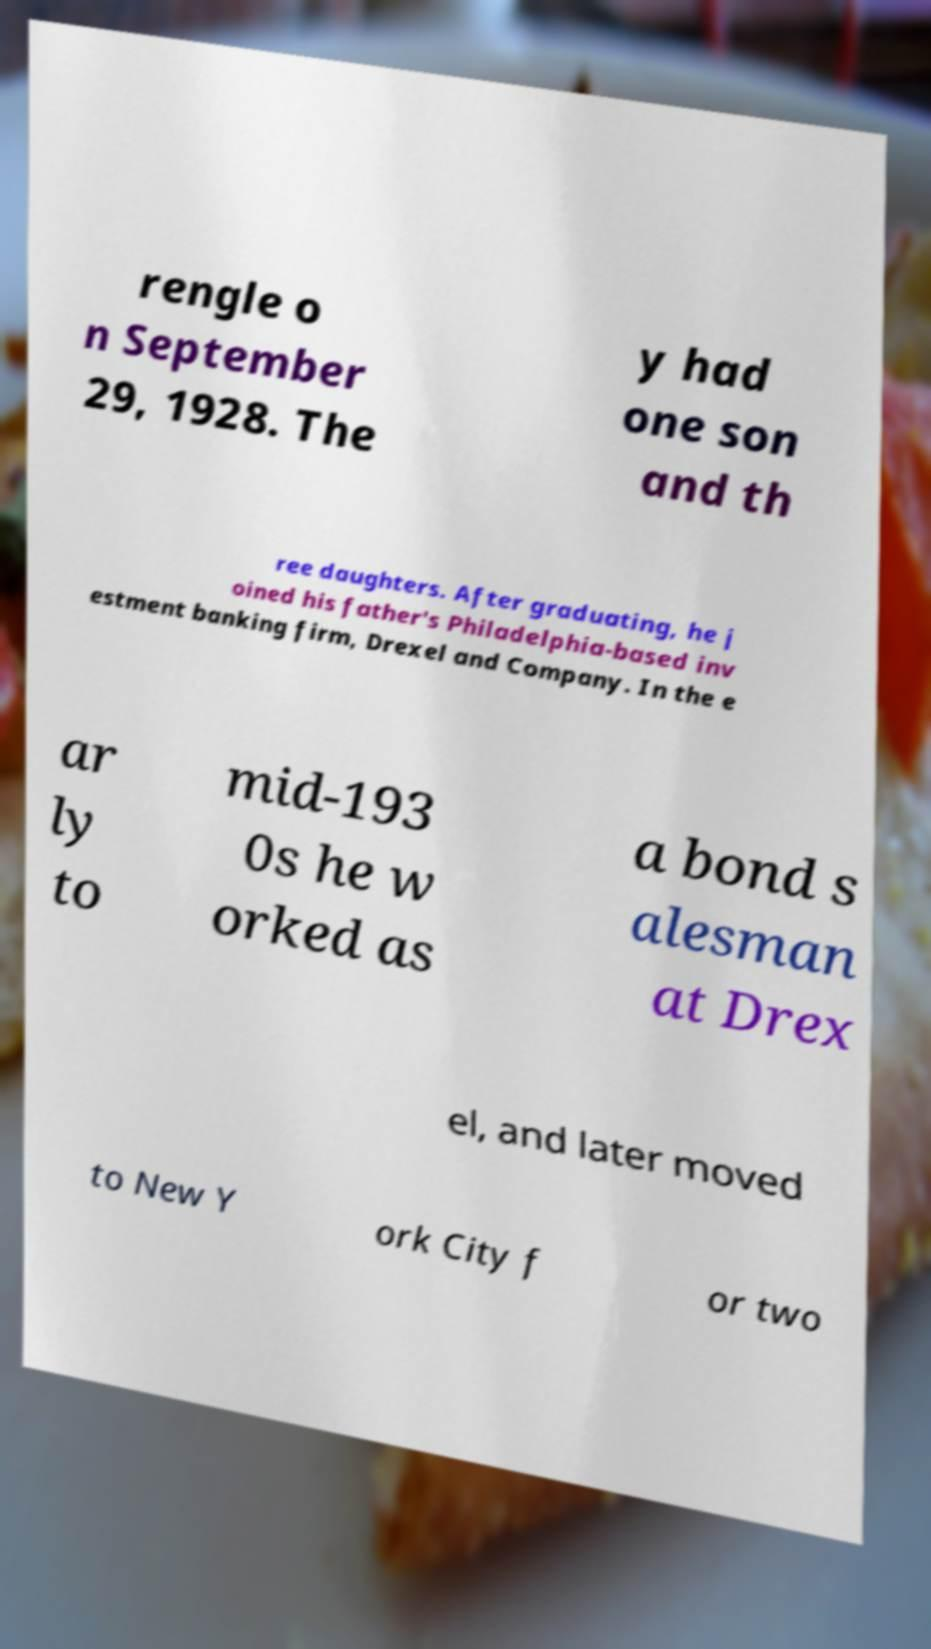Please read and relay the text visible in this image. What does it say? rengle o n September 29, 1928. The y had one son and th ree daughters. After graduating, he j oined his father's Philadelphia-based inv estment banking firm, Drexel and Company. In the e ar ly to mid-193 0s he w orked as a bond s alesman at Drex el, and later moved to New Y ork City f or two 